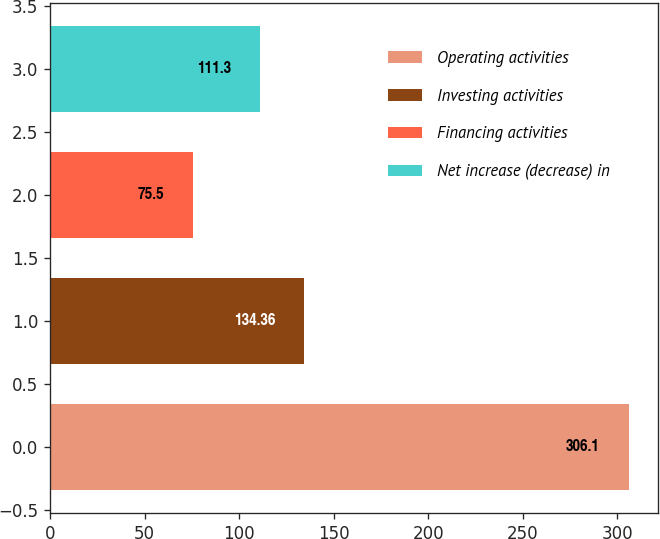<chart> <loc_0><loc_0><loc_500><loc_500><bar_chart><fcel>Operating activities<fcel>Investing activities<fcel>Financing activities<fcel>Net increase (decrease) in<nl><fcel>306.1<fcel>134.36<fcel>75.5<fcel>111.3<nl></chart> 